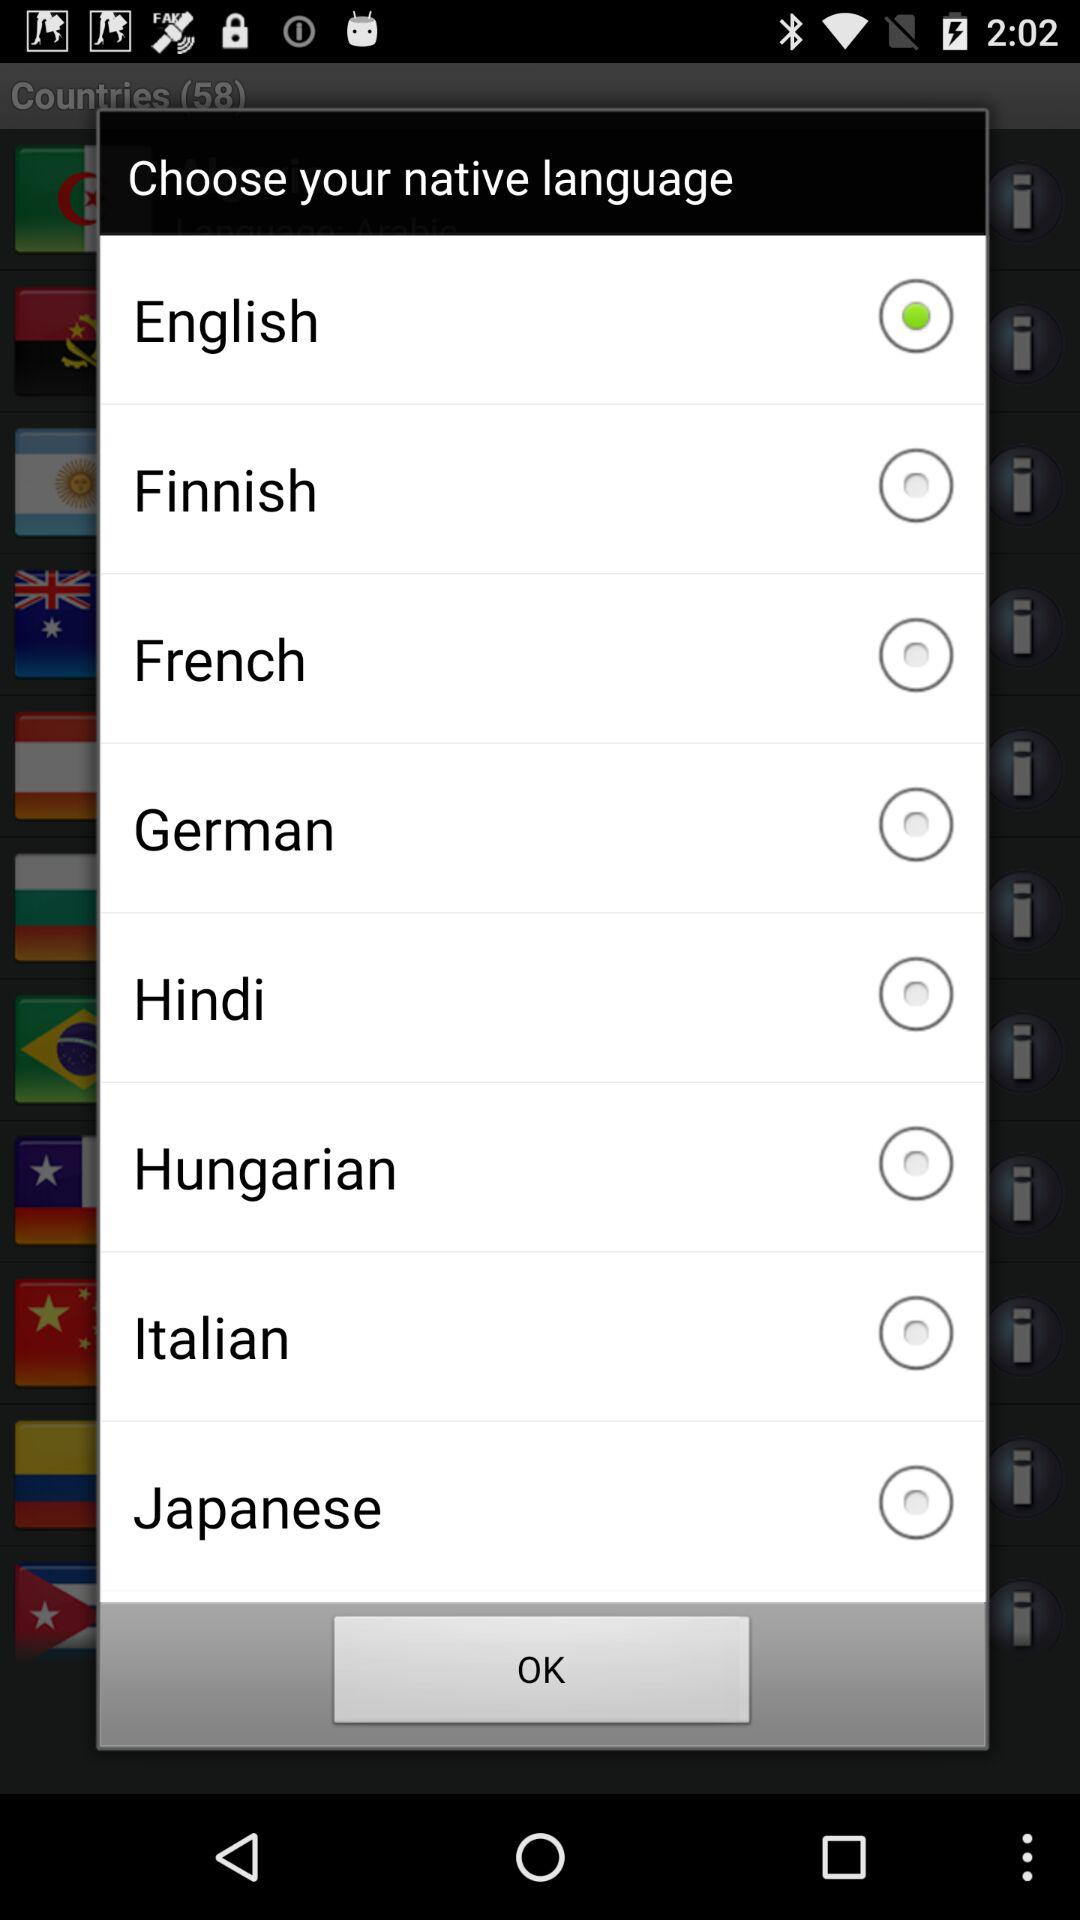Is "Hindi" selected? "Hindi" is not selected. 